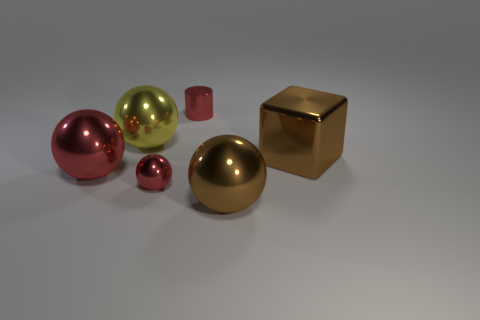What is the shape of the object that is the same color as the block?
Make the answer very short. Sphere. Is there anything else that has the same color as the tiny metallic ball?
Provide a short and direct response. Yes. Do the small metal cylinder and the small shiny sphere have the same color?
Your answer should be very brief. Yes. Do the big sphere that is to the right of the tiny red cylinder and the large cube have the same color?
Provide a short and direct response. Yes. Is there a small cylinder of the same color as the small sphere?
Give a very brief answer. Yes. What is the shape of the object that is left of the tiny metal ball and behind the brown shiny cube?
Ensure brevity in your answer.  Sphere. There is a small object that is in front of the tiny cylinder; does it have the same color as the object on the left side of the yellow shiny object?
Your answer should be compact. Yes. There is a cylinder that is the same color as the tiny metallic ball; what size is it?
Provide a short and direct response. Small. Is there a large red thing made of the same material as the big red ball?
Offer a very short reply. No. Are there an equal number of large cubes that are behind the small metallic cylinder and large objects to the left of the big brown shiny block?
Ensure brevity in your answer.  No. 